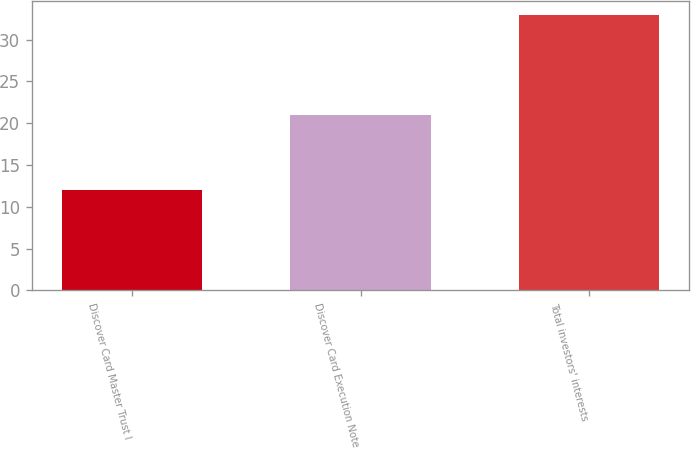Convert chart to OTSL. <chart><loc_0><loc_0><loc_500><loc_500><bar_chart><fcel>Discover Card Master Trust I<fcel>Discover Card Execution Note<fcel>Total investors' interests<nl><fcel>12<fcel>21<fcel>33<nl></chart> 